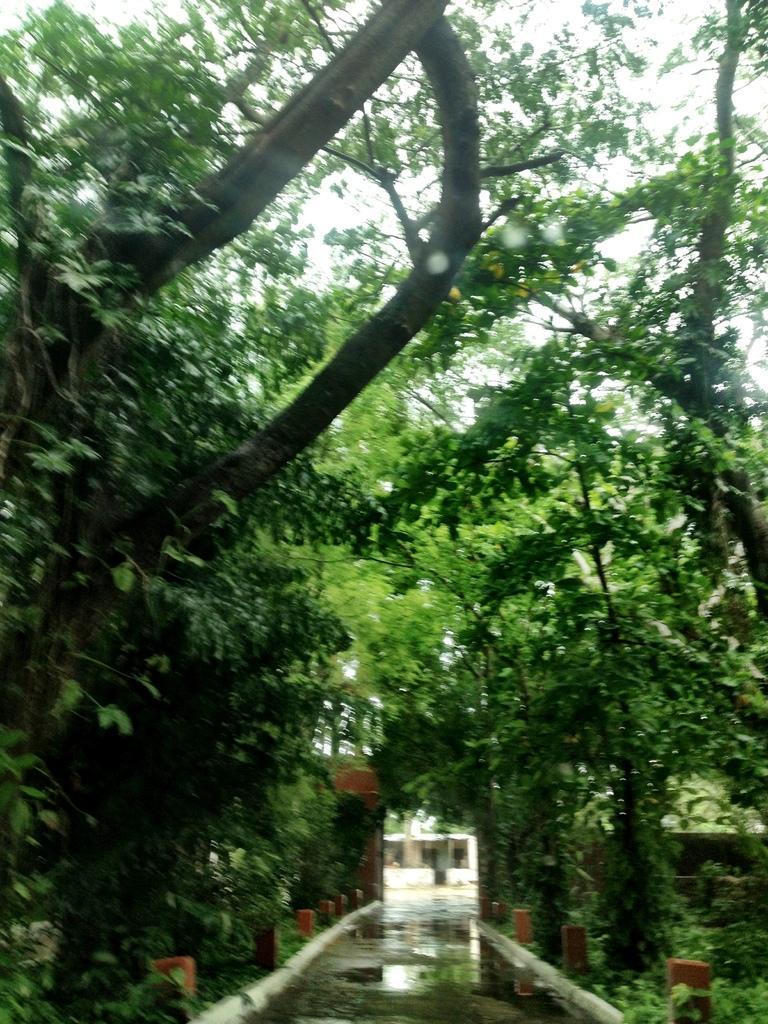Describe this image in one or two sentences. In the foreground of this image, at the bottom, there is a path and on either side there are bollard like objects and trees. At the top, there is the sky. 